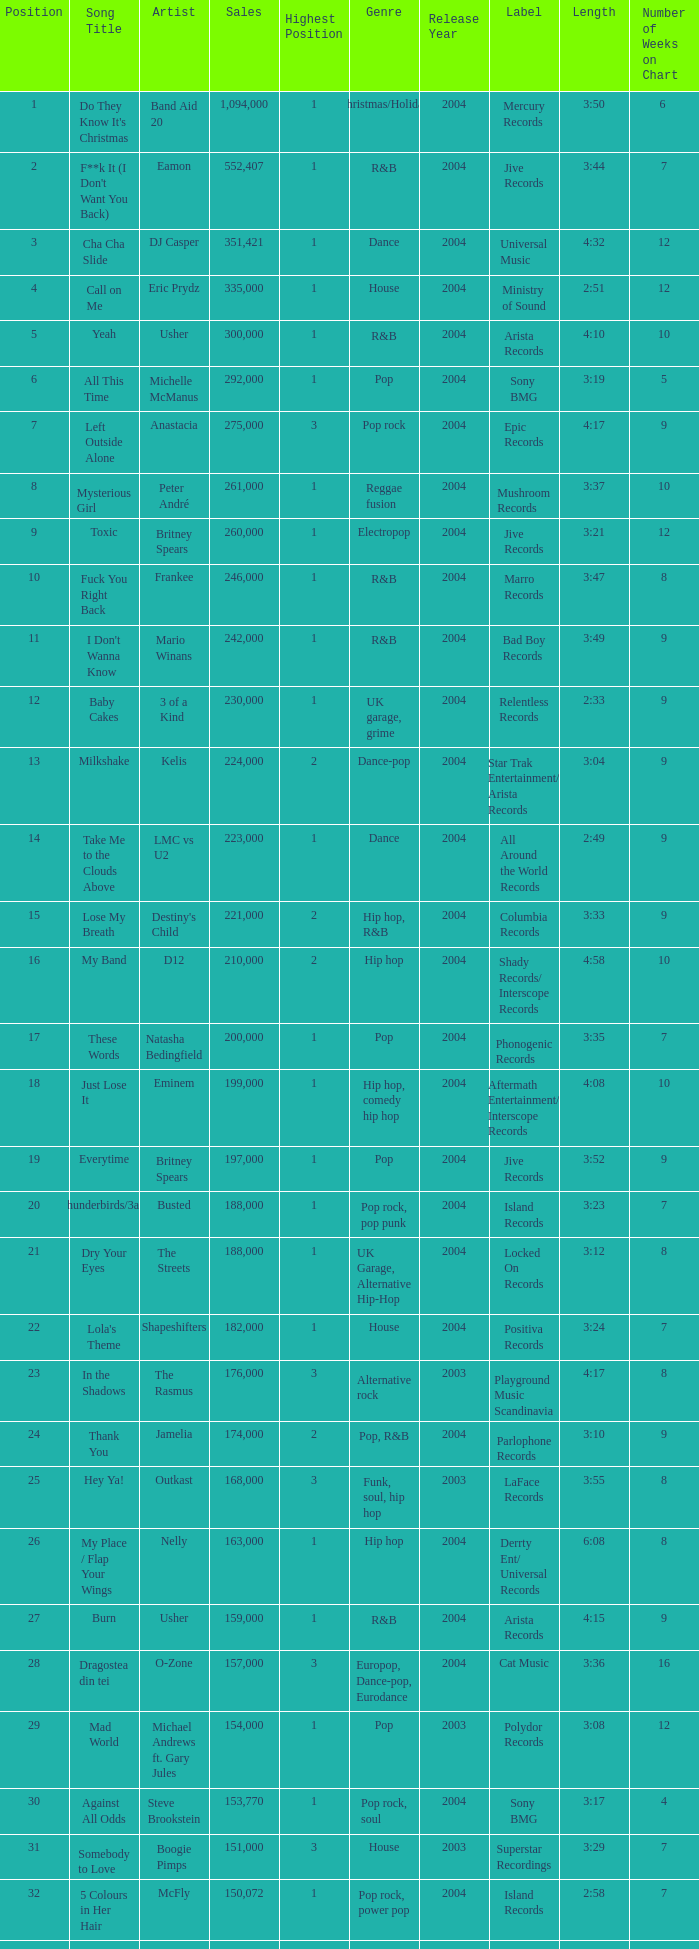What were the sales for Dj Casper when he was in a position lower than 13? 351421.0. 